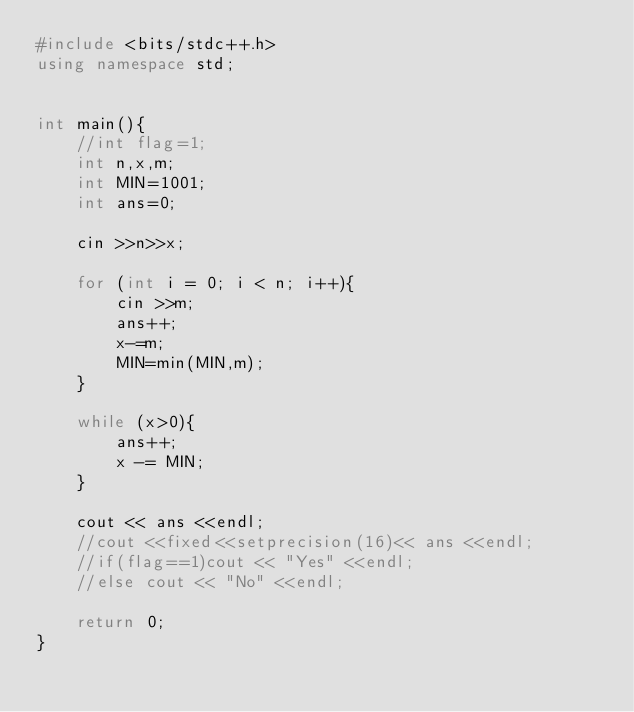Convert code to text. <code><loc_0><loc_0><loc_500><loc_500><_C++_>#include <bits/stdc++.h>
using namespace std;
    

int main(){
    //int flag=1;
    int n,x,m;
    int MIN=1001;
    int ans=0;

    cin >>n>>x;

    for (int i = 0; i < n; i++){
        cin >>m;
        ans++;
        x-=m;
        MIN=min(MIN,m);
    }

    while (x>0){
        ans++;
        x -= MIN;
    }
    
    cout << ans <<endl;
    //cout <<fixed<<setprecision(16)<< ans <<endl;
    //if(flag==1)cout << "Yes" <<endl;
    //else cout << "No" <<endl;
    
    return 0;
}
</code> 